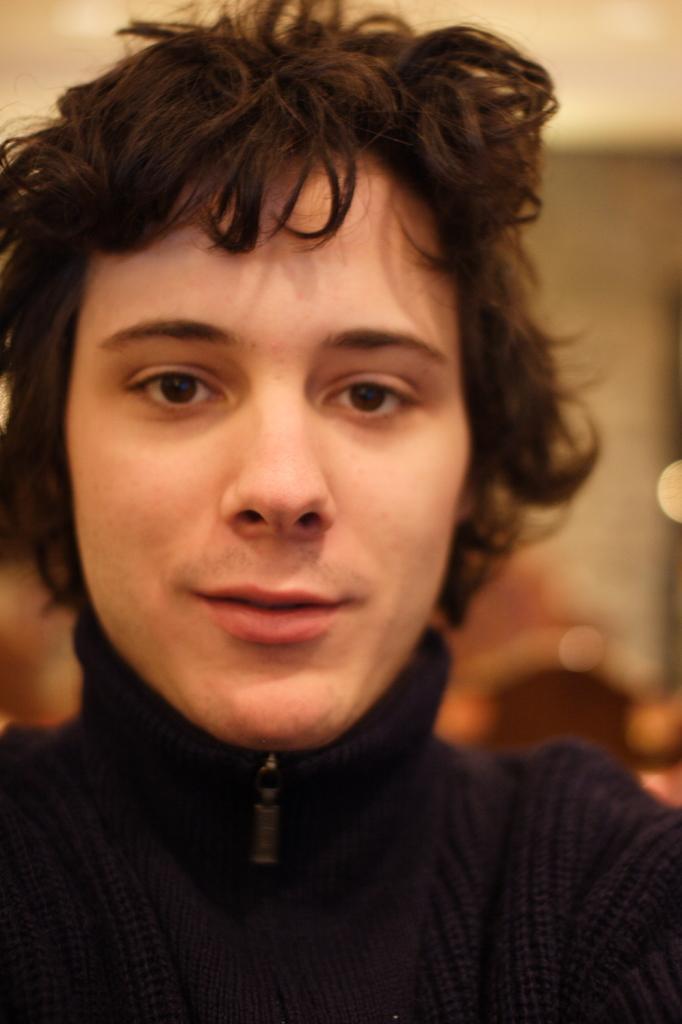Describe this image in one or two sentences. Here we can see a person and in the background the image is blur. 